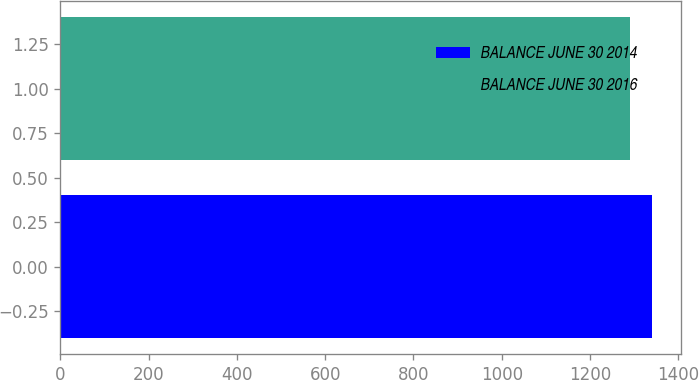Convert chart to OTSL. <chart><loc_0><loc_0><loc_500><loc_500><bar_chart><fcel>BALANCE JUNE 30 2014<fcel>BALANCE JUNE 30 2016<nl><fcel>1340<fcel>1290<nl></chart> 